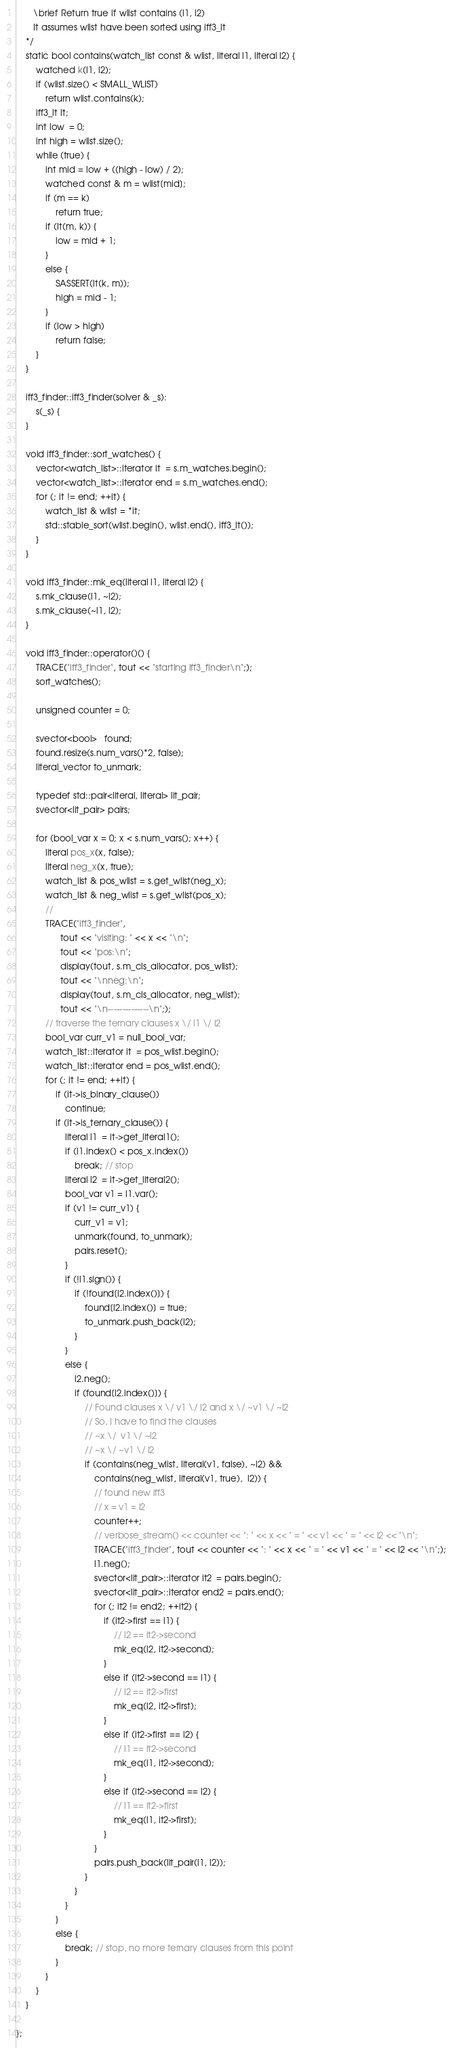<code> <loc_0><loc_0><loc_500><loc_500><_C++_>       \brief Return true if wlist contains (l1, l2)
       It assumes wlist have been sorted using iff3_lt
    */
    static bool contains(watch_list const & wlist, literal l1, literal l2) {
        watched k(l1, l2);
        if (wlist.size() < SMALL_WLIST)
            return wlist.contains(k);
        iff3_lt lt;
        int low  = 0;
        int high = wlist.size(); 
        while (true) {
            int mid = low + ((high - low) / 2);
            watched const & m = wlist[mid];
            if (m == k)
                return true;
            if (lt(m, k)) {
                low = mid + 1;
            }
            else {
                SASSERT(lt(k, m));
                high = mid - 1;
            }
            if (low > high)
                return false;
        }
    }

    iff3_finder::iff3_finder(solver & _s):
        s(_s) {
    }

    void iff3_finder::sort_watches() {
        vector<watch_list>::iterator it  = s.m_watches.begin();
        vector<watch_list>::iterator end = s.m_watches.end();
        for (; it != end; ++it) {
            watch_list & wlist = *it;
            std::stable_sort(wlist.begin(), wlist.end(), iff3_lt());
        }
    }

    void iff3_finder::mk_eq(literal l1, literal l2) {
        s.mk_clause(l1, ~l2);
        s.mk_clause(~l1, l2);
    }

    void iff3_finder::operator()() {
        TRACE("iff3_finder", tout << "starting iff3_finder\n";);
        sort_watches();
        
        unsigned counter = 0;

        svector<bool>   found;
        found.resize(s.num_vars()*2, false);
        literal_vector to_unmark;

        typedef std::pair<literal, literal> lit_pair;
        svector<lit_pair> pairs;

        for (bool_var x = 0; x < s.num_vars(); x++) {
            literal pos_x(x, false);
            literal neg_x(x, true);
            watch_list & pos_wlist = s.get_wlist(neg_x);
            watch_list & neg_wlist = s.get_wlist(pos_x);
            // 
            TRACE("iff3_finder", 
                  tout << "visiting: " << x << "\n";
                  tout << "pos:\n";
                  display(tout, s.m_cls_allocator, pos_wlist);
                  tout << "\nneg:\n";
                  display(tout, s.m_cls_allocator, neg_wlist);
                  tout << "\n--------------\n";);
            // traverse the ternary clauses x \/ l1 \/ l2
            bool_var curr_v1 = null_bool_var;
            watch_list::iterator it  = pos_wlist.begin();
            watch_list::iterator end = pos_wlist.end();
            for (; it != end; ++it) {
                if (it->is_binary_clause())
                    continue;
                if (it->is_ternary_clause()) {
                    literal l1  = it->get_literal1();
                    if (l1.index() < pos_x.index())
                        break; // stop
                    literal l2  = it->get_literal2();
                    bool_var v1 = l1.var();
                    if (v1 != curr_v1) {
                        curr_v1 = v1;
                        unmark(found, to_unmark);
                        pairs.reset();
                    }
                    if (!l1.sign()) {
                        if (!found[l2.index()]) {
                            found[l2.index()] = true;
                            to_unmark.push_back(l2);
                        }
                    }
                    else {
                        l2.neg();
                        if (found[l2.index()]) {
                            // Found clauses x \/ v1 \/ l2 and x \/ ~v1 \/ ~l2
                            // So, I have to find the clauses
                            // ~x \/  v1 \/ ~l2
                            // ~x \/ ~v1 \/ l2
                            if (contains(neg_wlist, literal(v1, false), ~l2) &&
                                contains(neg_wlist, literal(v1, true),  l2)) {
                                // found new iff3
                                // x = v1 = l2
                                counter++;
                                // verbose_stream() << counter << ": " << x << " = " << v1 << " = " << l2 << "\n";
                                TRACE("iff3_finder", tout << counter << ": " << x << " = " << v1 << " = " << l2 << "\n";);
                                l1.neg();
                                svector<lit_pair>::iterator it2  = pairs.begin();
                                svector<lit_pair>::iterator end2 = pairs.end();
                                for (; it2 != end2; ++it2) {
                                    if (it2->first == l1) {
                                        // l2 == it2->second
                                        mk_eq(l2, it2->second);
                                    }
                                    else if (it2->second == l1) {
                                        // l2 == it2->first
                                        mk_eq(l2, it2->first);
                                    }
                                    else if (it2->first == l2) {
                                        // l1 == it2->second
                                        mk_eq(l1, it2->second);
                                    }
                                    else if (it2->second == l2) {
                                        // l1 == it2->first
                                        mk_eq(l1, it2->first);
                                    }
                                }
                                pairs.push_back(lit_pair(l1, l2));
                            }
                        }
                    }
                }
                else {
                    break; // stop, no more ternary clauses from this point
                }
            }
        }
    }
    
};
</code> 